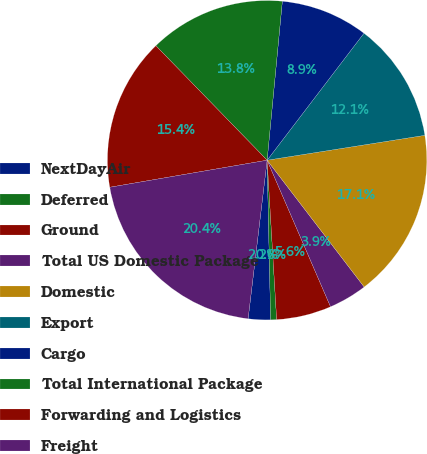Convert chart. <chart><loc_0><loc_0><loc_500><loc_500><pie_chart><fcel>NextDayAir<fcel>Deferred<fcel>Ground<fcel>Total US Domestic Package<fcel>Domestic<fcel>Export<fcel>Cargo<fcel>Total International Package<fcel>Forwarding and Logistics<fcel>Freight<nl><fcel>2.25%<fcel>0.6%<fcel>5.55%<fcel>3.9%<fcel>17.09%<fcel>12.14%<fcel>8.85%<fcel>13.79%<fcel>15.44%<fcel>20.39%<nl></chart> 